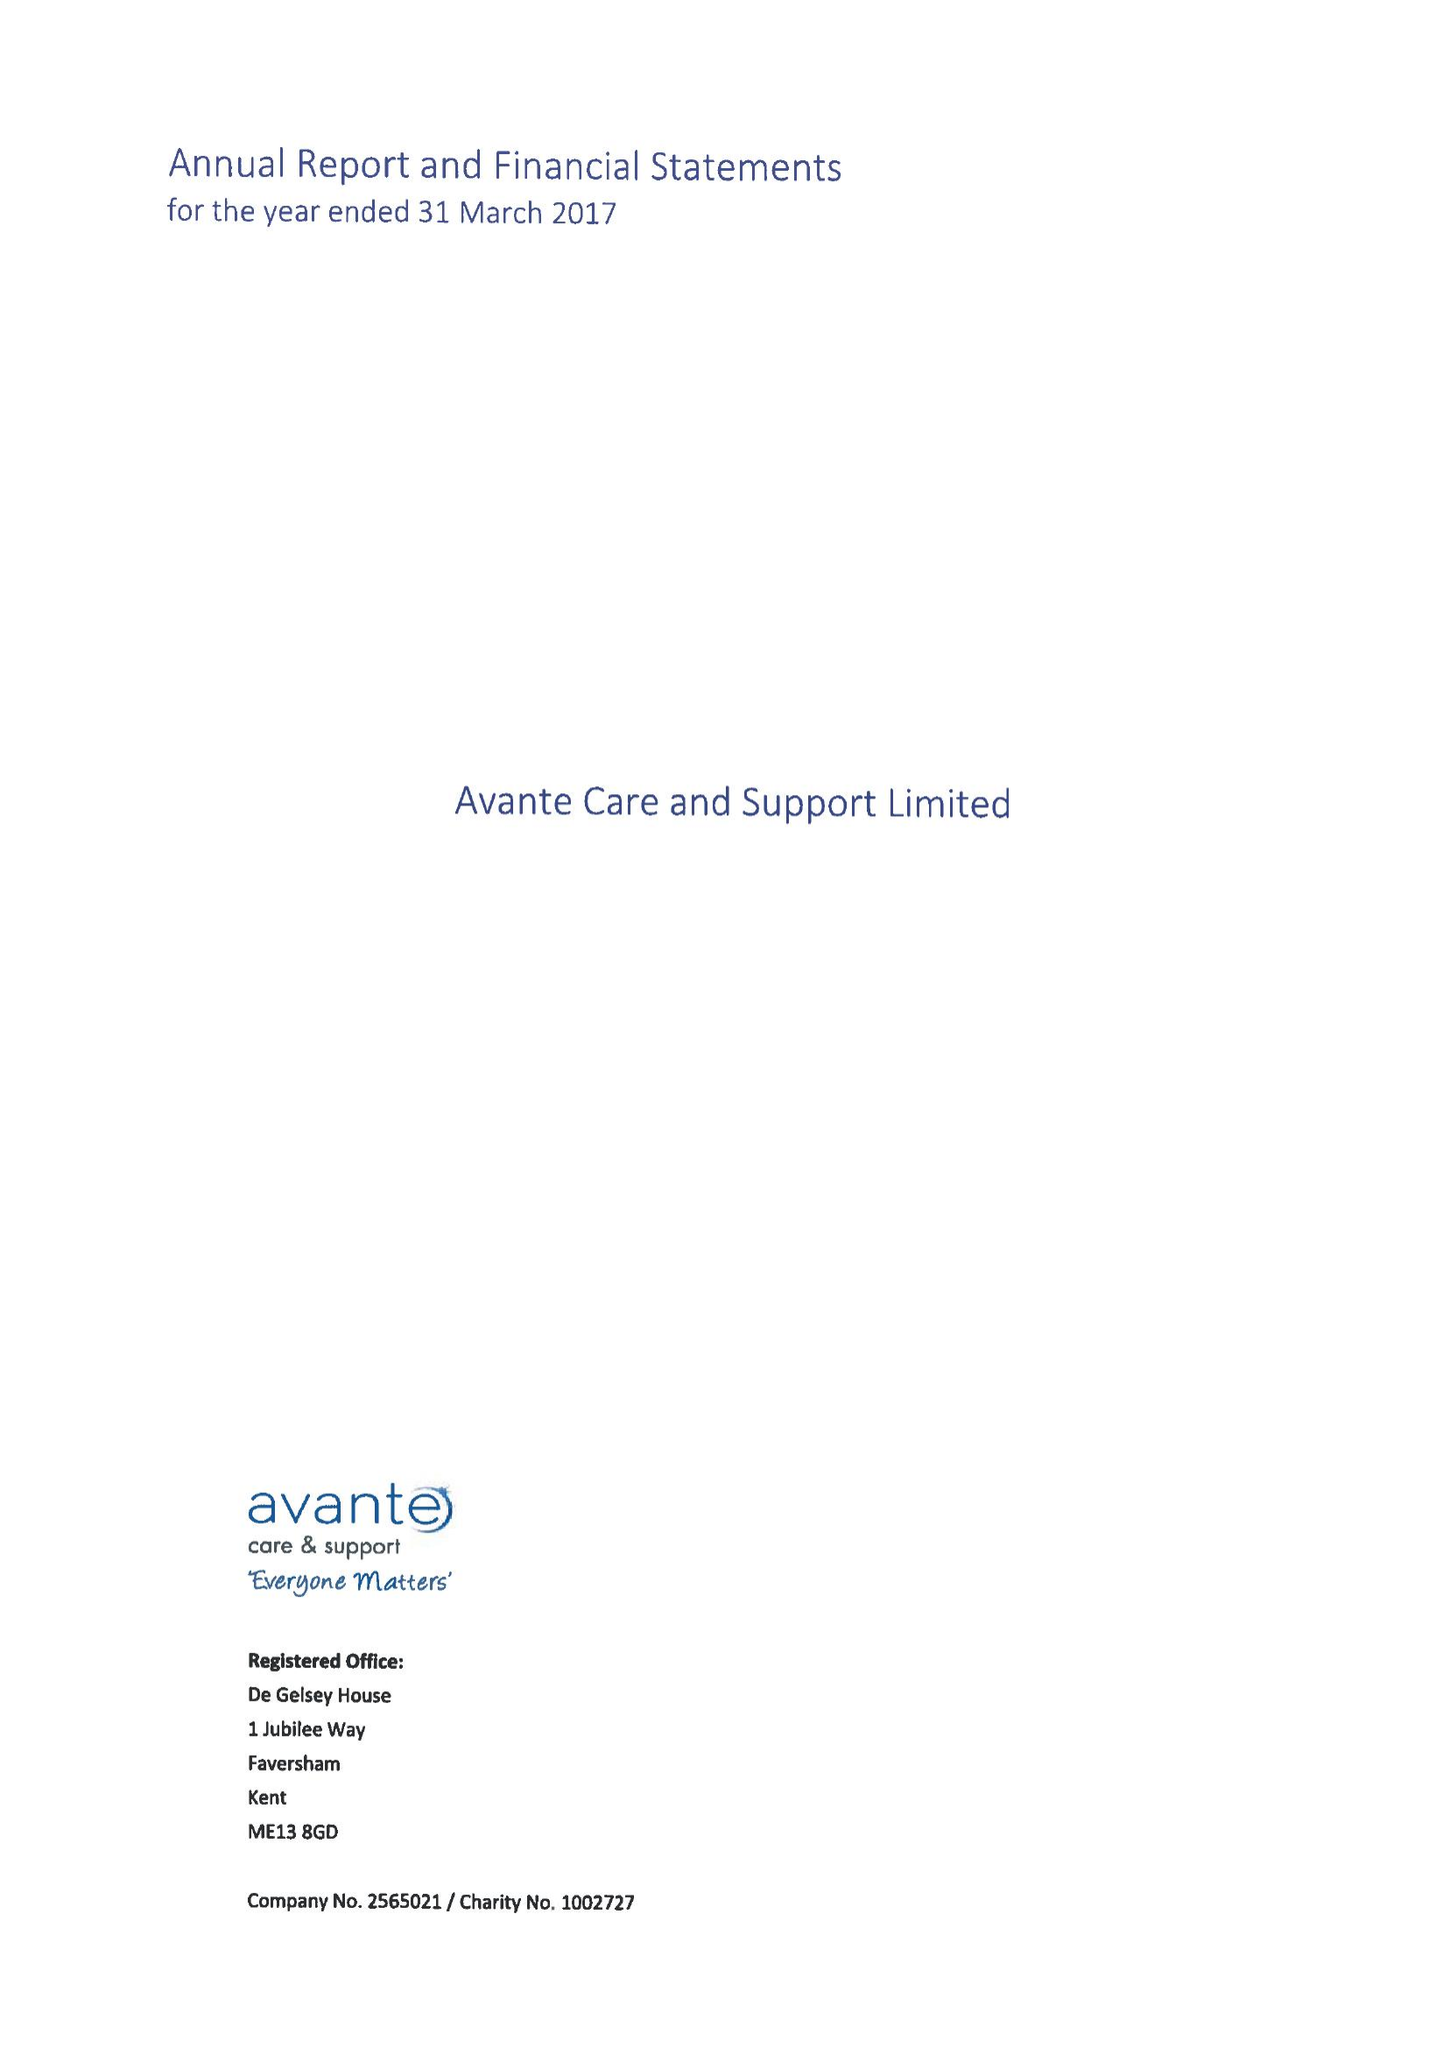What is the value for the charity_name?
Answer the question using a single word or phrase. Avante Care and Support Ltd. 